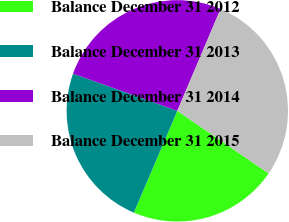Convert chart. <chart><loc_0><loc_0><loc_500><loc_500><pie_chart><fcel>Balance December 31 2012<fcel>Balance December 31 2013<fcel>Balance December 31 2014<fcel>Balance December 31 2015<nl><fcel>21.86%<fcel>24.03%<fcel>25.93%<fcel>28.17%<nl></chart> 